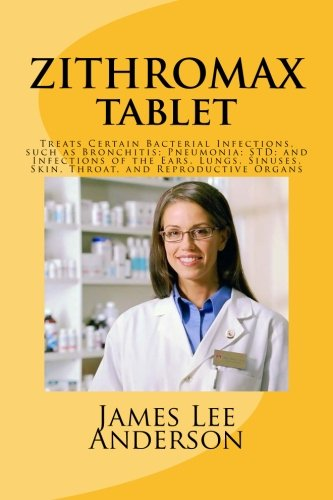Can you tell me more about the uses of Zithromax mentioned on this book cover? Zithromax is an antibiotic that treats a variety of bacterial infections. Based on the book cover, it's used for bronchitis, pneumonia, sexually transmitted diseases (STDs), and infections of the ears, lungs, sinuses, skin, throat, and reproductive organs. 